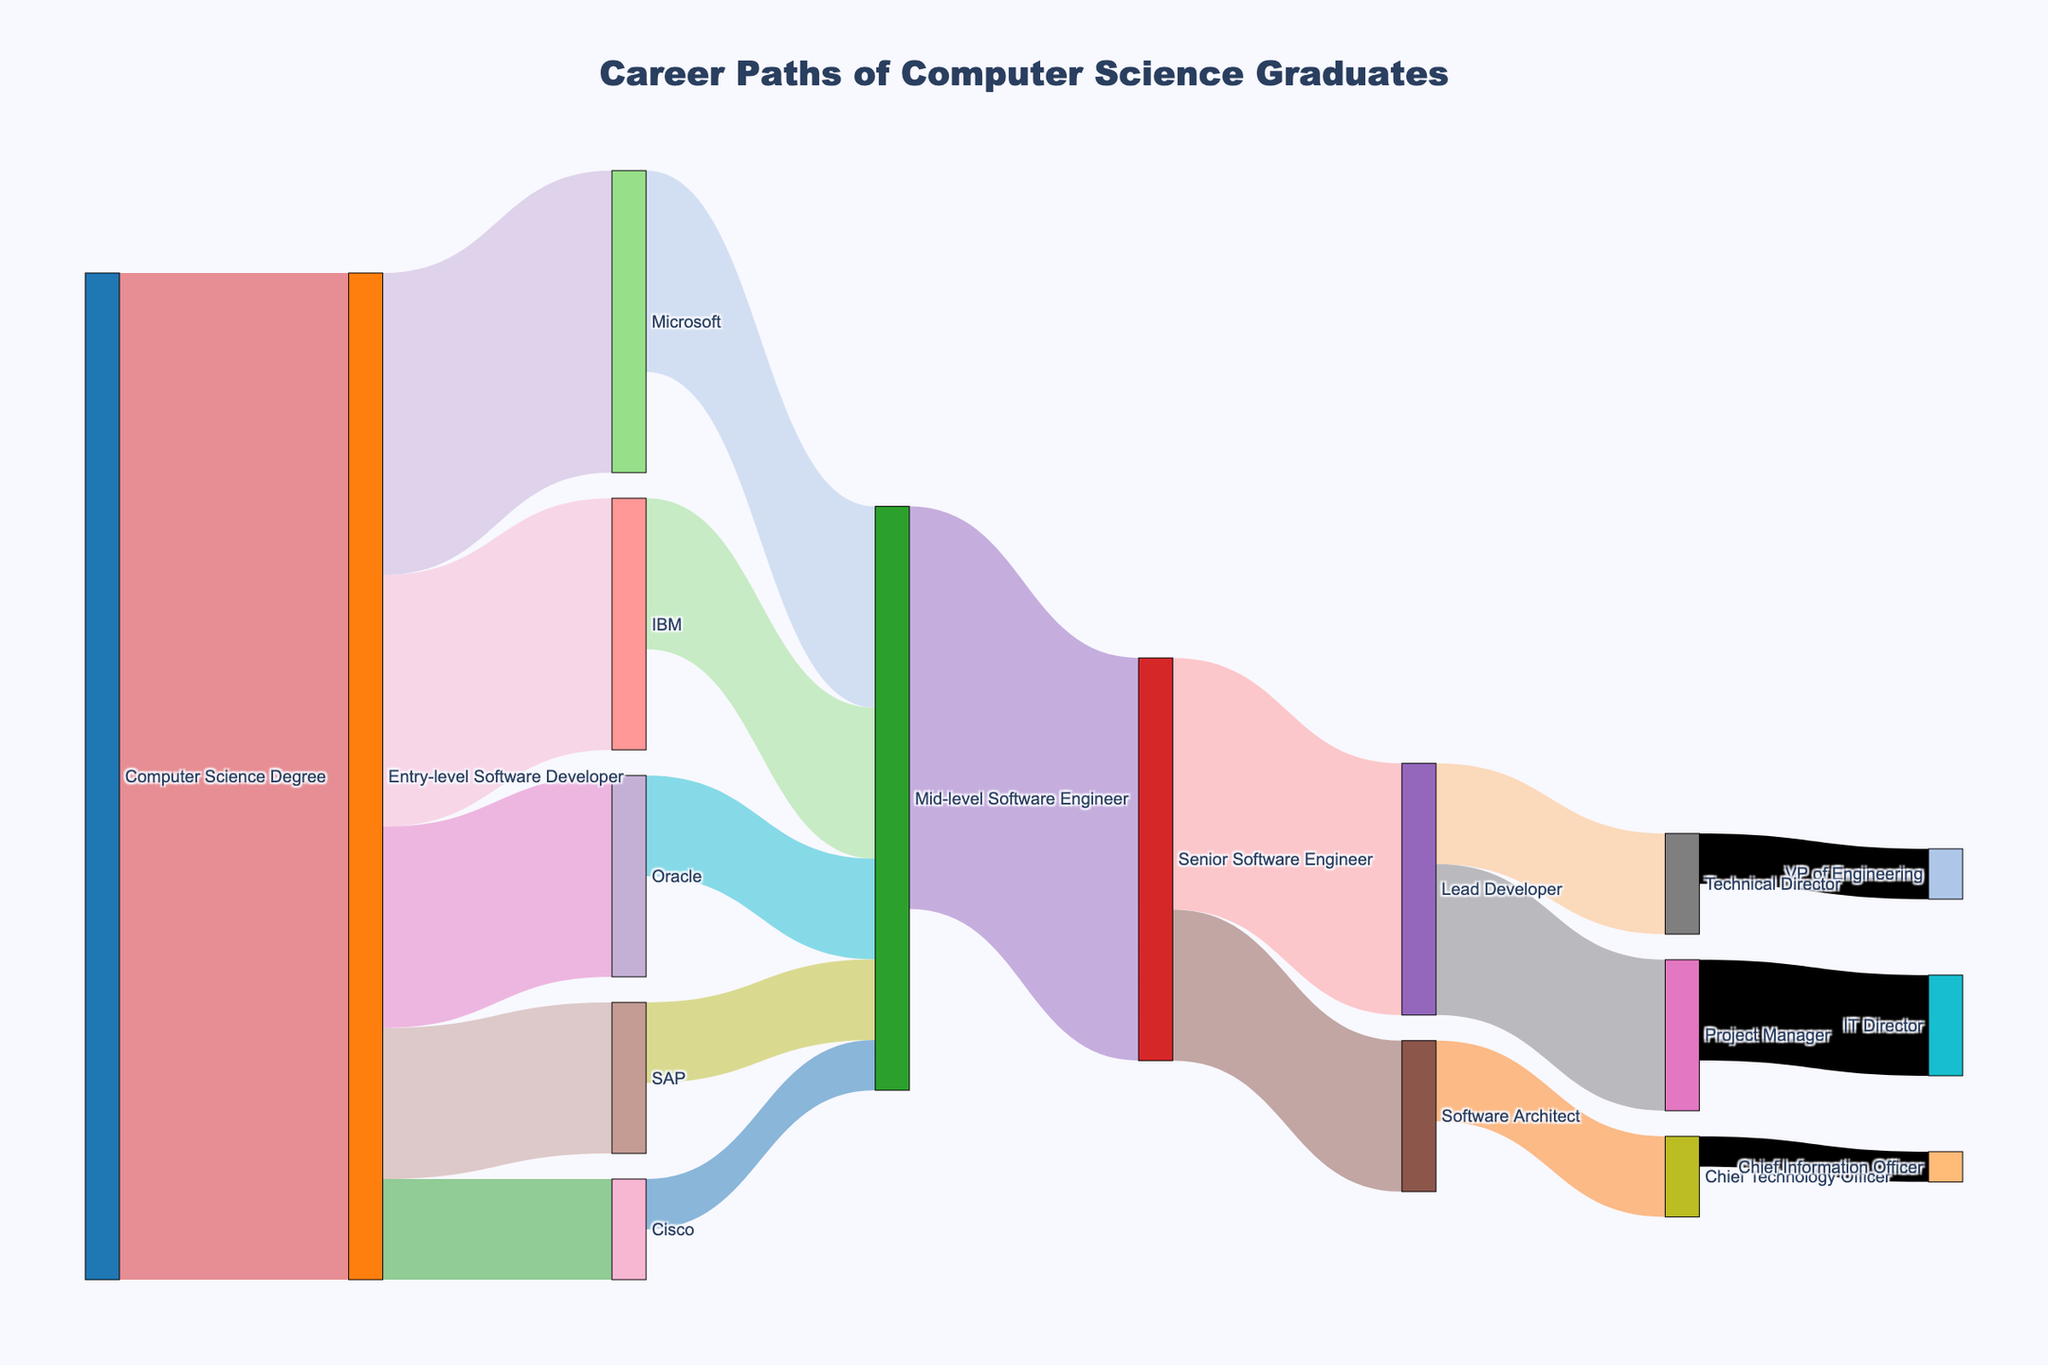What is the title of the figure? The title is located at the top of the figure, usually in a larger or bold font. Here, it reads "Career Paths of Computer Science Graduates."
Answer: Career Paths of Computer Science Graduates Which company employs the most entry-level software developers? By following the path from "Entry-level Software Developer," see which target company node receives the largest value. Microsoft employs 30 entry-level software developers, which is the highest.
Answer: Microsoft How many people move from a Mid-level Software Engineer to a Senior Software Engineer? Follow the path from "Mid-level Software Engineer" to "Senior Software Engineer." The value associated with this path is 40.
Answer: 40 Which role is directly promoted from Lead Developer? Follow the paths originating from "Lead Developer." The roles promoted directly from Lead Developer are "Project Manager" and "Technical Director."
Answer: Project Manager and Technical Director How many roles are there between an Entry-level Software Developer and a Project Manager? Trace the path from "Entry-level Software Developer" to "Project Manager." The roles in between are "Mid-level Software Engineer," "Senior Software Engineer," and "Lead Developer," making it 3 roles.
Answer: 3 How many individuals eventually become a Chief Technology Officer? Trace the paths leading to "Chief Technology Officer." From "Software Architect" to "Chief Technology Officer," the value is 8.
Answer: 8 What are the possible roles Senior Software Engineers can be promoted to? Follow the paths from "Senior Software Engineer." The possible roles are "Lead Developer" and "Software Architect."
Answer: Lead Developer and Software Architect What is the combined total number of people working at IBM and Oracle as entry-level software developers? Add the values for "IBM" and "Oracle" under the "Entry-level Software Developer" path. IBM employs 25 and Oracle employs 20, summing to 45.
Answer: 45 Compare the number of people becoming IT Directors to those becoming VPs of Engineering. Which role has more individuals? Count the number of individuals going to "IT Director" and "VP of Engineering." "IT Director" has 10, while "VP of Engineering" has 5. Therefore, IT Director has more individuals.
Answer: IT Director What is the most common final role within the career path shown? Follow all the paths to their final nodes. "Lead Developer" culminates in "Project Manager" and "Technical Director"; considering all these paths, the most common final role appears to be "Project Manager" with a sum of 15 individuals.
Answer: Project Manager 